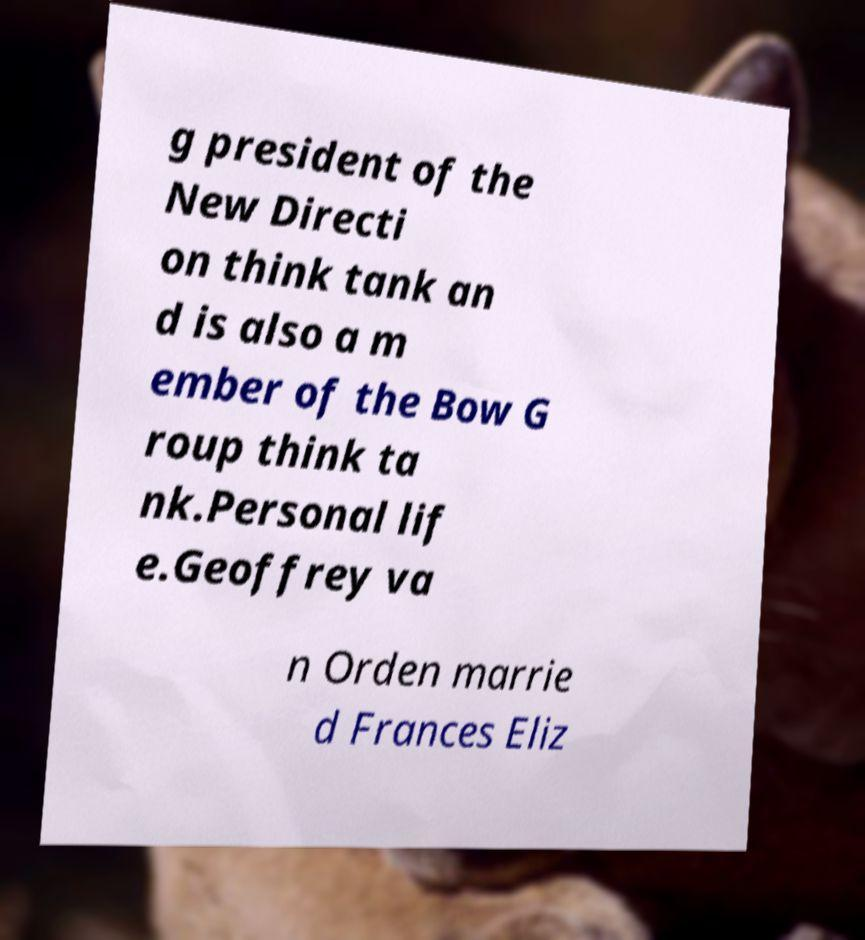Can you read and provide the text displayed in the image?This photo seems to have some interesting text. Can you extract and type it out for me? g president of the New Directi on think tank an d is also a m ember of the Bow G roup think ta nk.Personal lif e.Geoffrey va n Orden marrie d Frances Eliz 